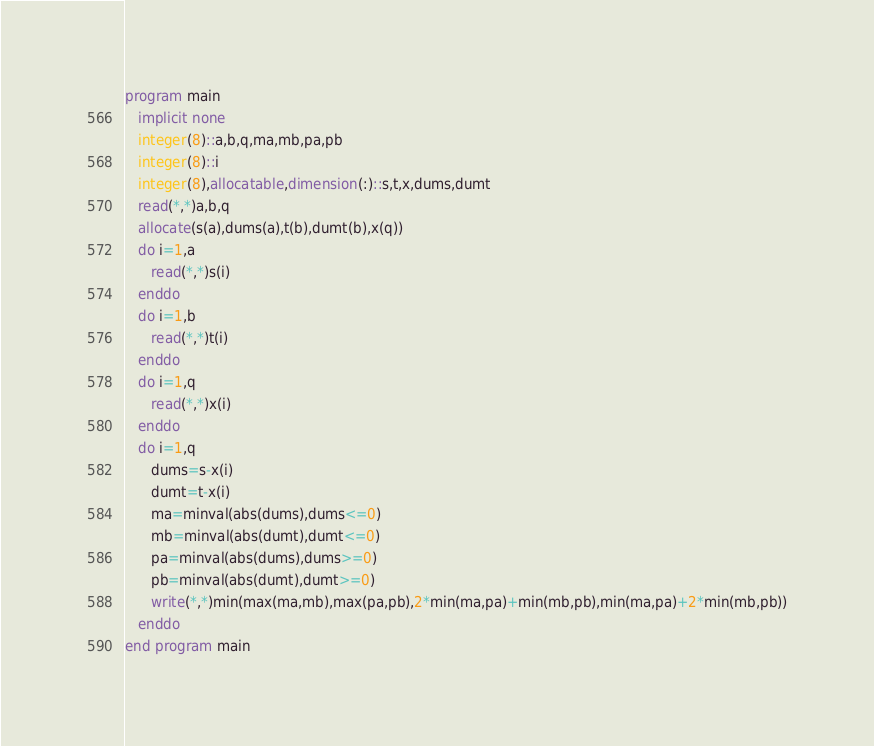Convert code to text. <code><loc_0><loc_0><loc_500><loc_500><_FORTRAN_>program main
   implicit none
   integer(8)::a,b,q,ma,mb,pa,pb
   integer(8)::i
   integer(8),allocatable,dimension(:)::s,t,x,dums,dumt
   read(*,*)a,b,q
   allocate(s(a),dums(a),t(b),dumt(b),x(q))
   do i=1,a
      read(*,*)s(i)
   enddo
   do i=1,b
      read(*,*)t(i)
   enddo 
   do i=1,q
      read(*,*)x(i)
   enddo
   do i=1,q
      dums=s-x(i)
      dumt=t-x(i)
      ma=minval(abs(dums),dums<=0)
      mb=minval(abs(dumt),dumt<=0)
      pa=minval(abs(dums),dums>=0)
      pb=minval(abs(dumt),dumt>=0)
      write(*,*)min(max(ma,mb),max(pa,pb),2*min(ma,pa)+min(mb,pb),min(ma,pa)+2*min(mb,pb))
   enddo
end program main
</code> 